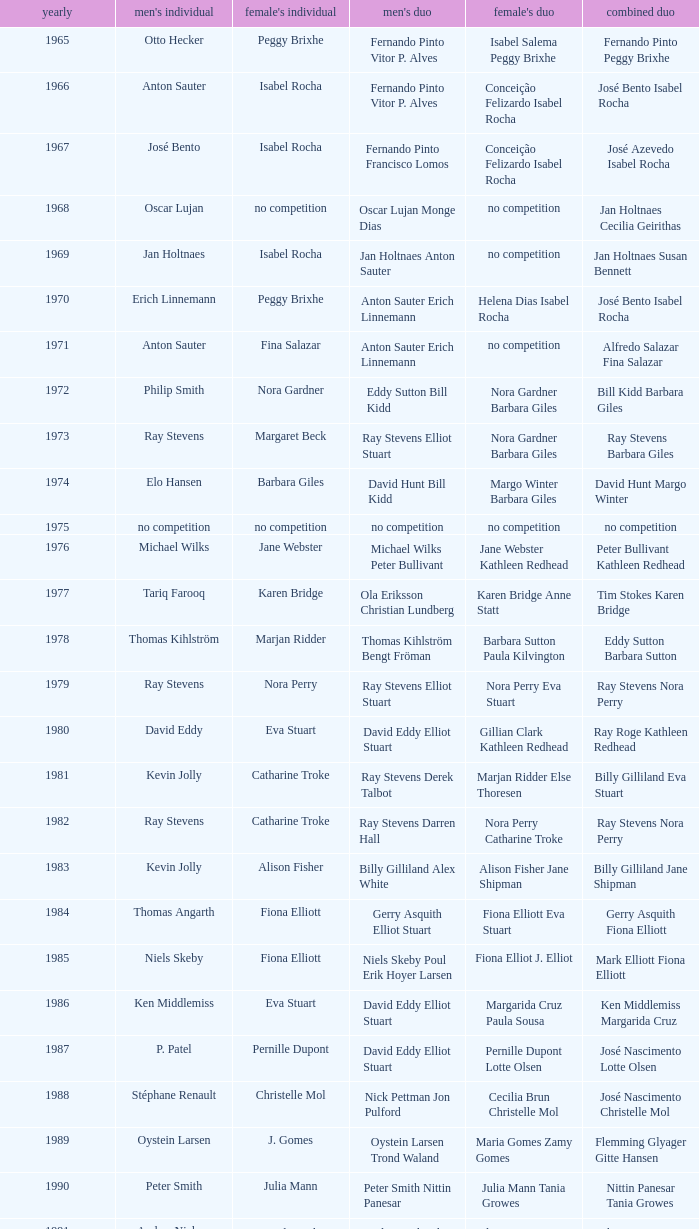What is the average year with alfredo salazar fina salazar in mixed doubles? 1971.0. 